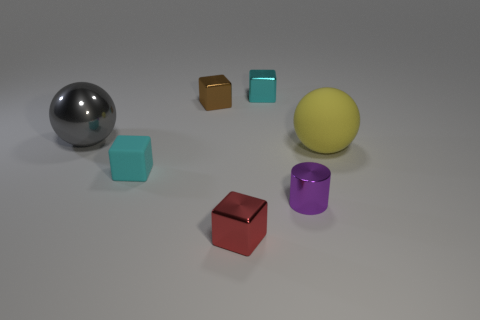Add 3 green rubber balls. How many objects exist? 10 Subtract all cylinders. How many objects are left? 6 Subtract 0 purple balls. How many objects are left? 7 Subtract all purple metallic cylinders. Subtract all large metal objects. How many objects are left? 5 Add 3 red shiny cubes. How many red shiny cubes are left? 4 Add 6 big blue shiny blocks. How many big blue shiny blocks exist? 6 